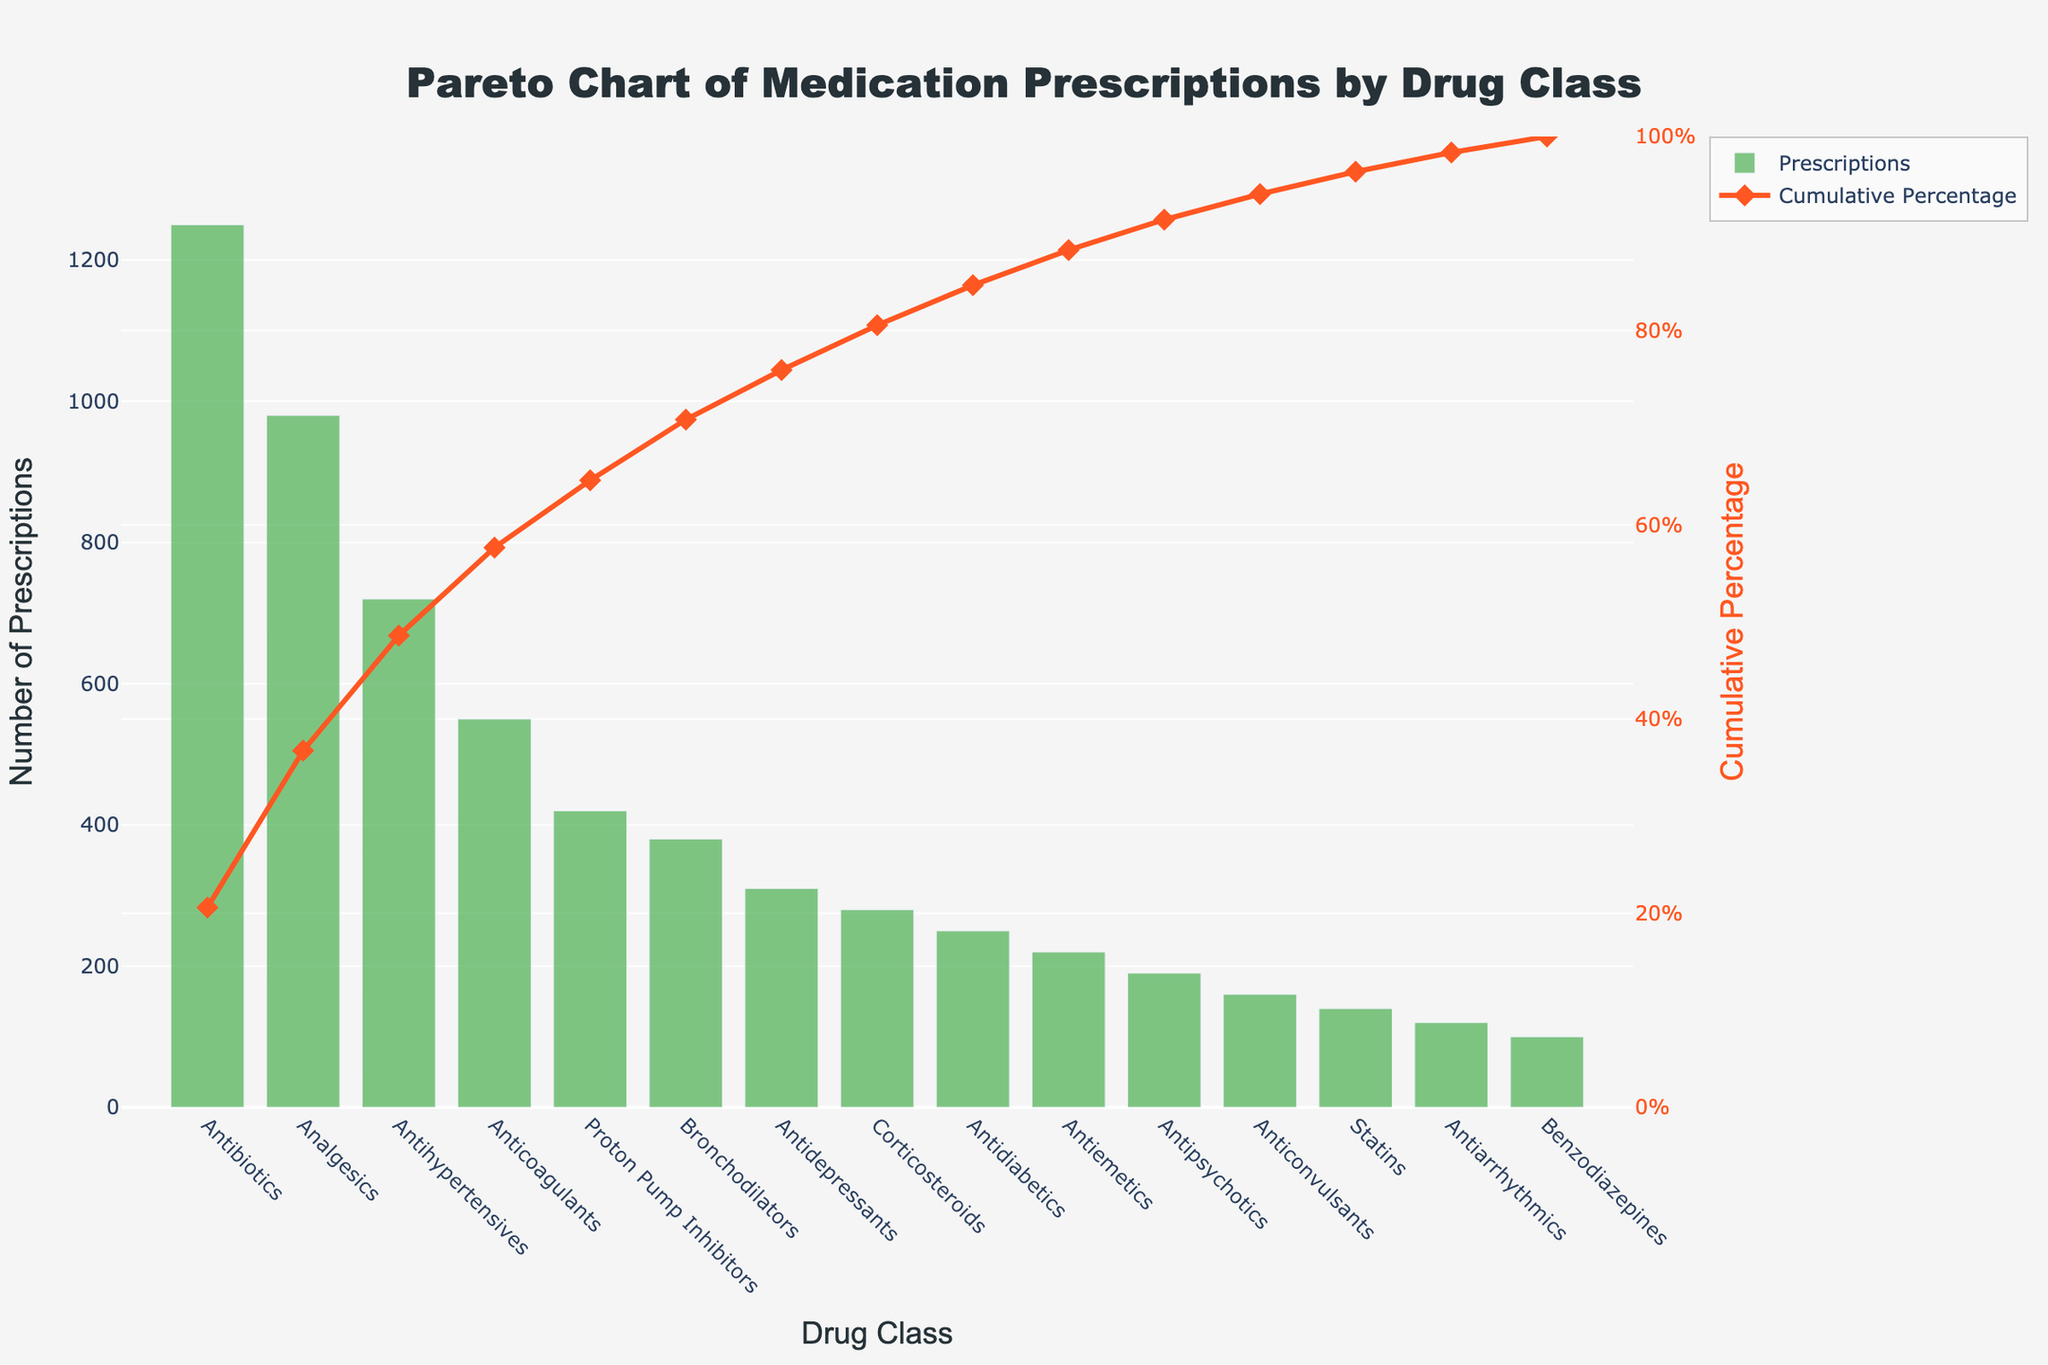What is the title of the chart? The title is usually located at the top of the plot, centered, and provides an immediate understanding of the chart content. In this case, it reads, "Pareto Chart of Medication Prescriptions by Drug Class."
Answer: Pareto Chart of Medication Prescriptions by Drug Class Which drug class has the highest number of prescriptions? We can identify the drug class with the highest number by looking at the tallest bar in the bar section of the Pareto chart. In this case, the tallest bar represents "Antibiotics," indicating it has the highest number of prescriptions.
Answer: Antibiotics What is the cumulative percentage for Analgesics? Locate the data point for Analgesics and examine the corresponding point on the cumulative percentage line (marked by diamond symbols). The cumulative percentage for Analgesics ends at 43.92%.
Answer: 43.92% Which drug class has fewer prescriptions: Anticoagulants or Statins? By looking at the heights of the respective bars for Anticoagulants and Statins, we can see that Anticoagulants have a higher bar than Statins. Therefore, Anticoagulants have more prescriptions, and Statins have fewer.
Answer: Statins What is the cumulative percentage for the first three classes of drugs (Antibiotics, Analgesics, and Antihypertensives)? Locate the cumulative percentage for Antihypertensives in the line graph, which represents the sum of the percentages for the first three drug classes. The cumulative percentage at Antihypertensives is 69.81%.
Answer: 69.81% How does the number of prescriptions for Bronchodilators compare to Proton Pump Inhibitors? Compare the height of the bars for Bronchodilators and Proton Pump Inhibitors; Proton Pump Inhibitors have a taller bar than Bronchodilators, indicating a higher number of prescriptions.
Answer: Proton Pump Inhibitors have more prescriptions Which drug class does the cumulative percentage line first intersect with a percentage exceeding 50%? Follow the cumulative percentage line and identify the first intersection it makes with a value exceeding 50%. By looking at the line, this happens at Antihypertensives, which has a cumulative percentage of 69.81%.
Answer: Antihypertensives What can you say about the distribution of prescriptions between the top three drug classes vs. the rest? Calculate the cumulative percentage for the top three drug classes (69.81%) and compare that to 100%, showing that the top three classes account for almost 70% of all prescriptions. The remaining drug classes combine to make up the remaining 30%.
Answer: The top three drug classes account for almost 70% of all prescriptions 